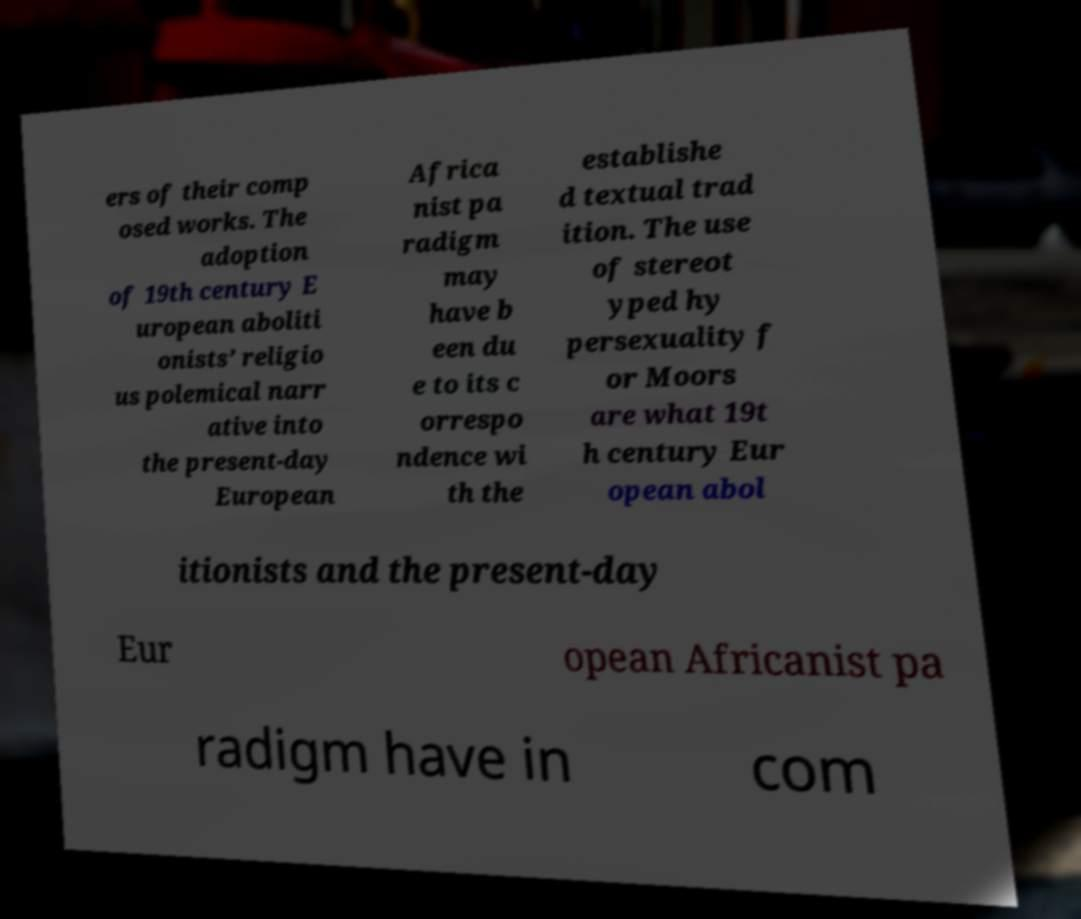Please read and relay the text visible in this image. What does it say? ers of their comp osed works. The adoption of 19th century E uropean aboliti onists’ religio us polemical narr ative into the present-day European Africa nist pa radigm may have b een du e to its c orrespo ndence wi th the establishe d textual trad ition. The use of stereot yped hy persexuality f or Moors are what 19t h century Eur opean abol itionists and the present-day Eur opean Africanist pa radigm have in com 